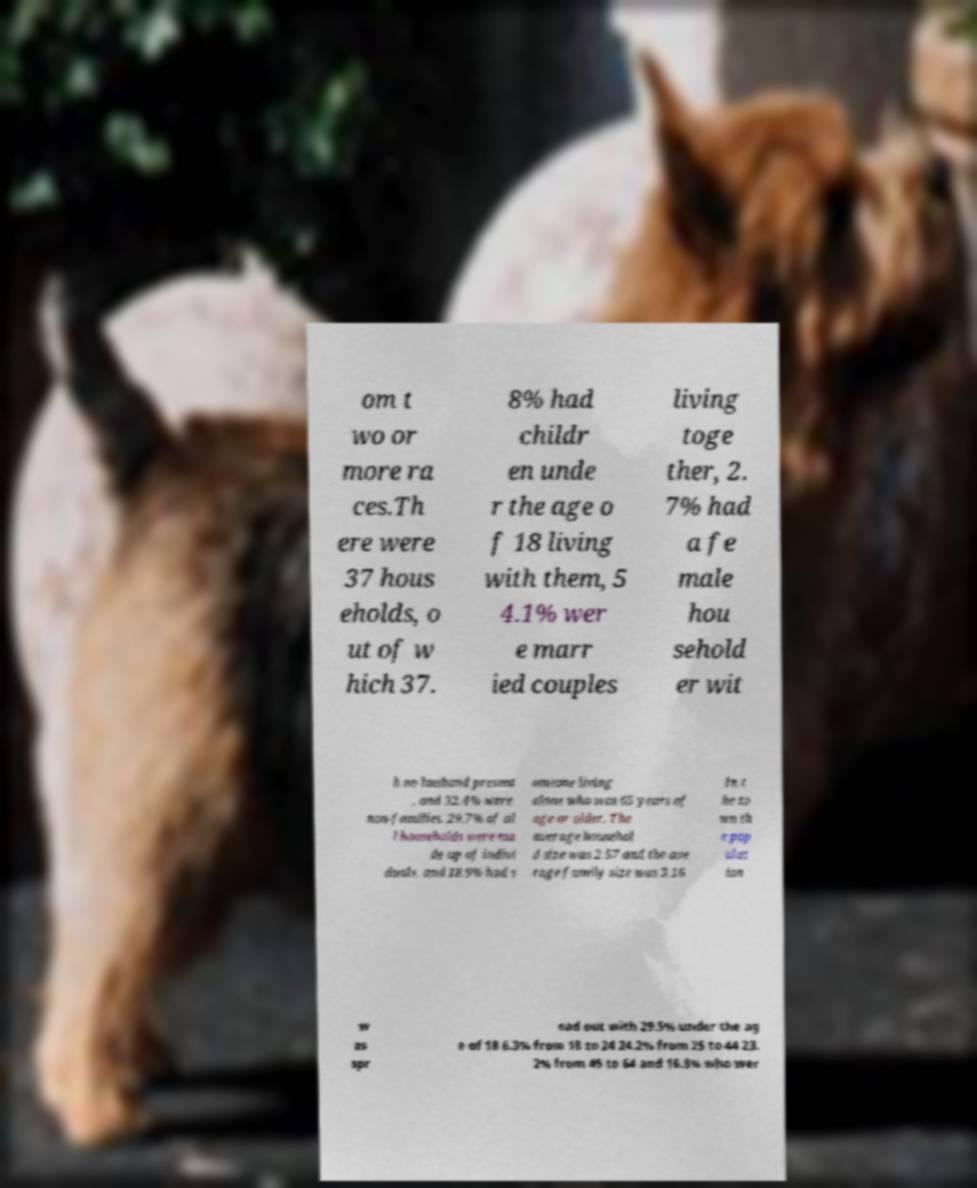There's text embedded in this image that I need extracted. Can you transcribe it verbatim? om t wo or more ra ces.Th ere were 37 hous eholds, o ut of w hich 37. 8% had childr en unde r the age o f 18 living with them, 5 4.1% wer e marr ied couples living toge ther, 2. 7% had a fe male hou sehold er wit h no husband present , and 32.4% were non-families. 29.7% of al l households were ma de up of indivi duals, and 18.9% had s omeone living alone who was 65 years of age or older. The average househol d size was 2.57 and the ave rage family size was 3.16. In t he to wn th e pop ulat ion w as spr ead out with 29.5% under the ag e of 18 6.3% from 18 to 24 24.2% from 25 to 44 23. 2% from 45 to 64 and 16.8% who wer 